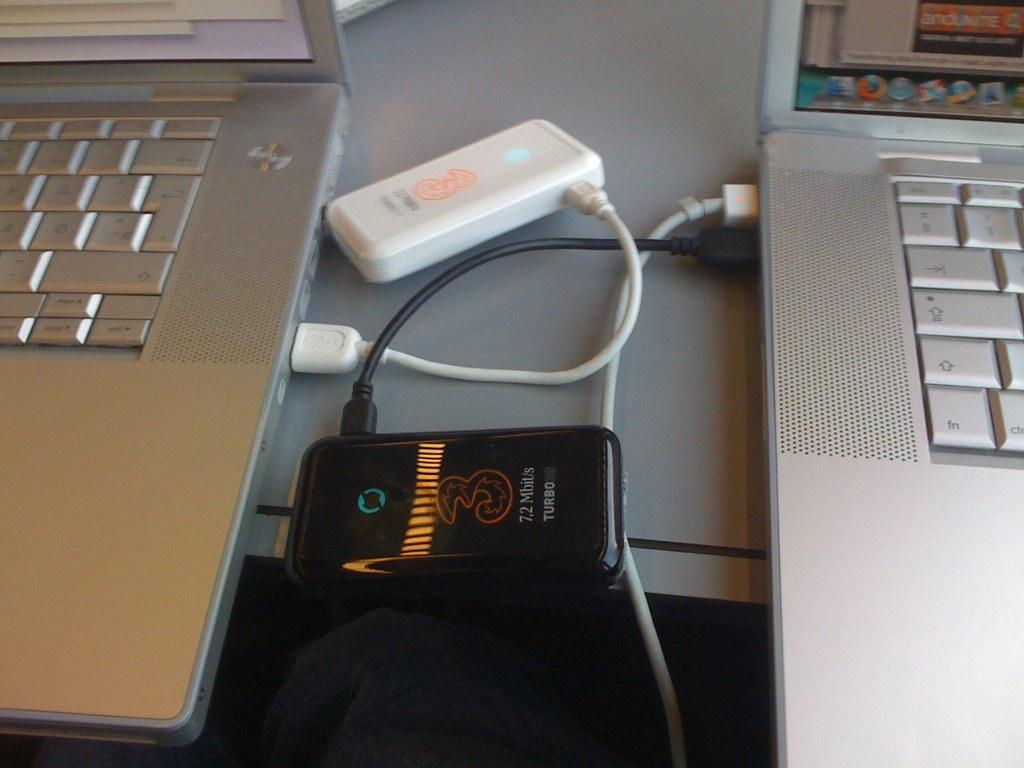<image>
Create a compact narrative representing the image presented. A device that says Turbo on it is in between two laptops. 